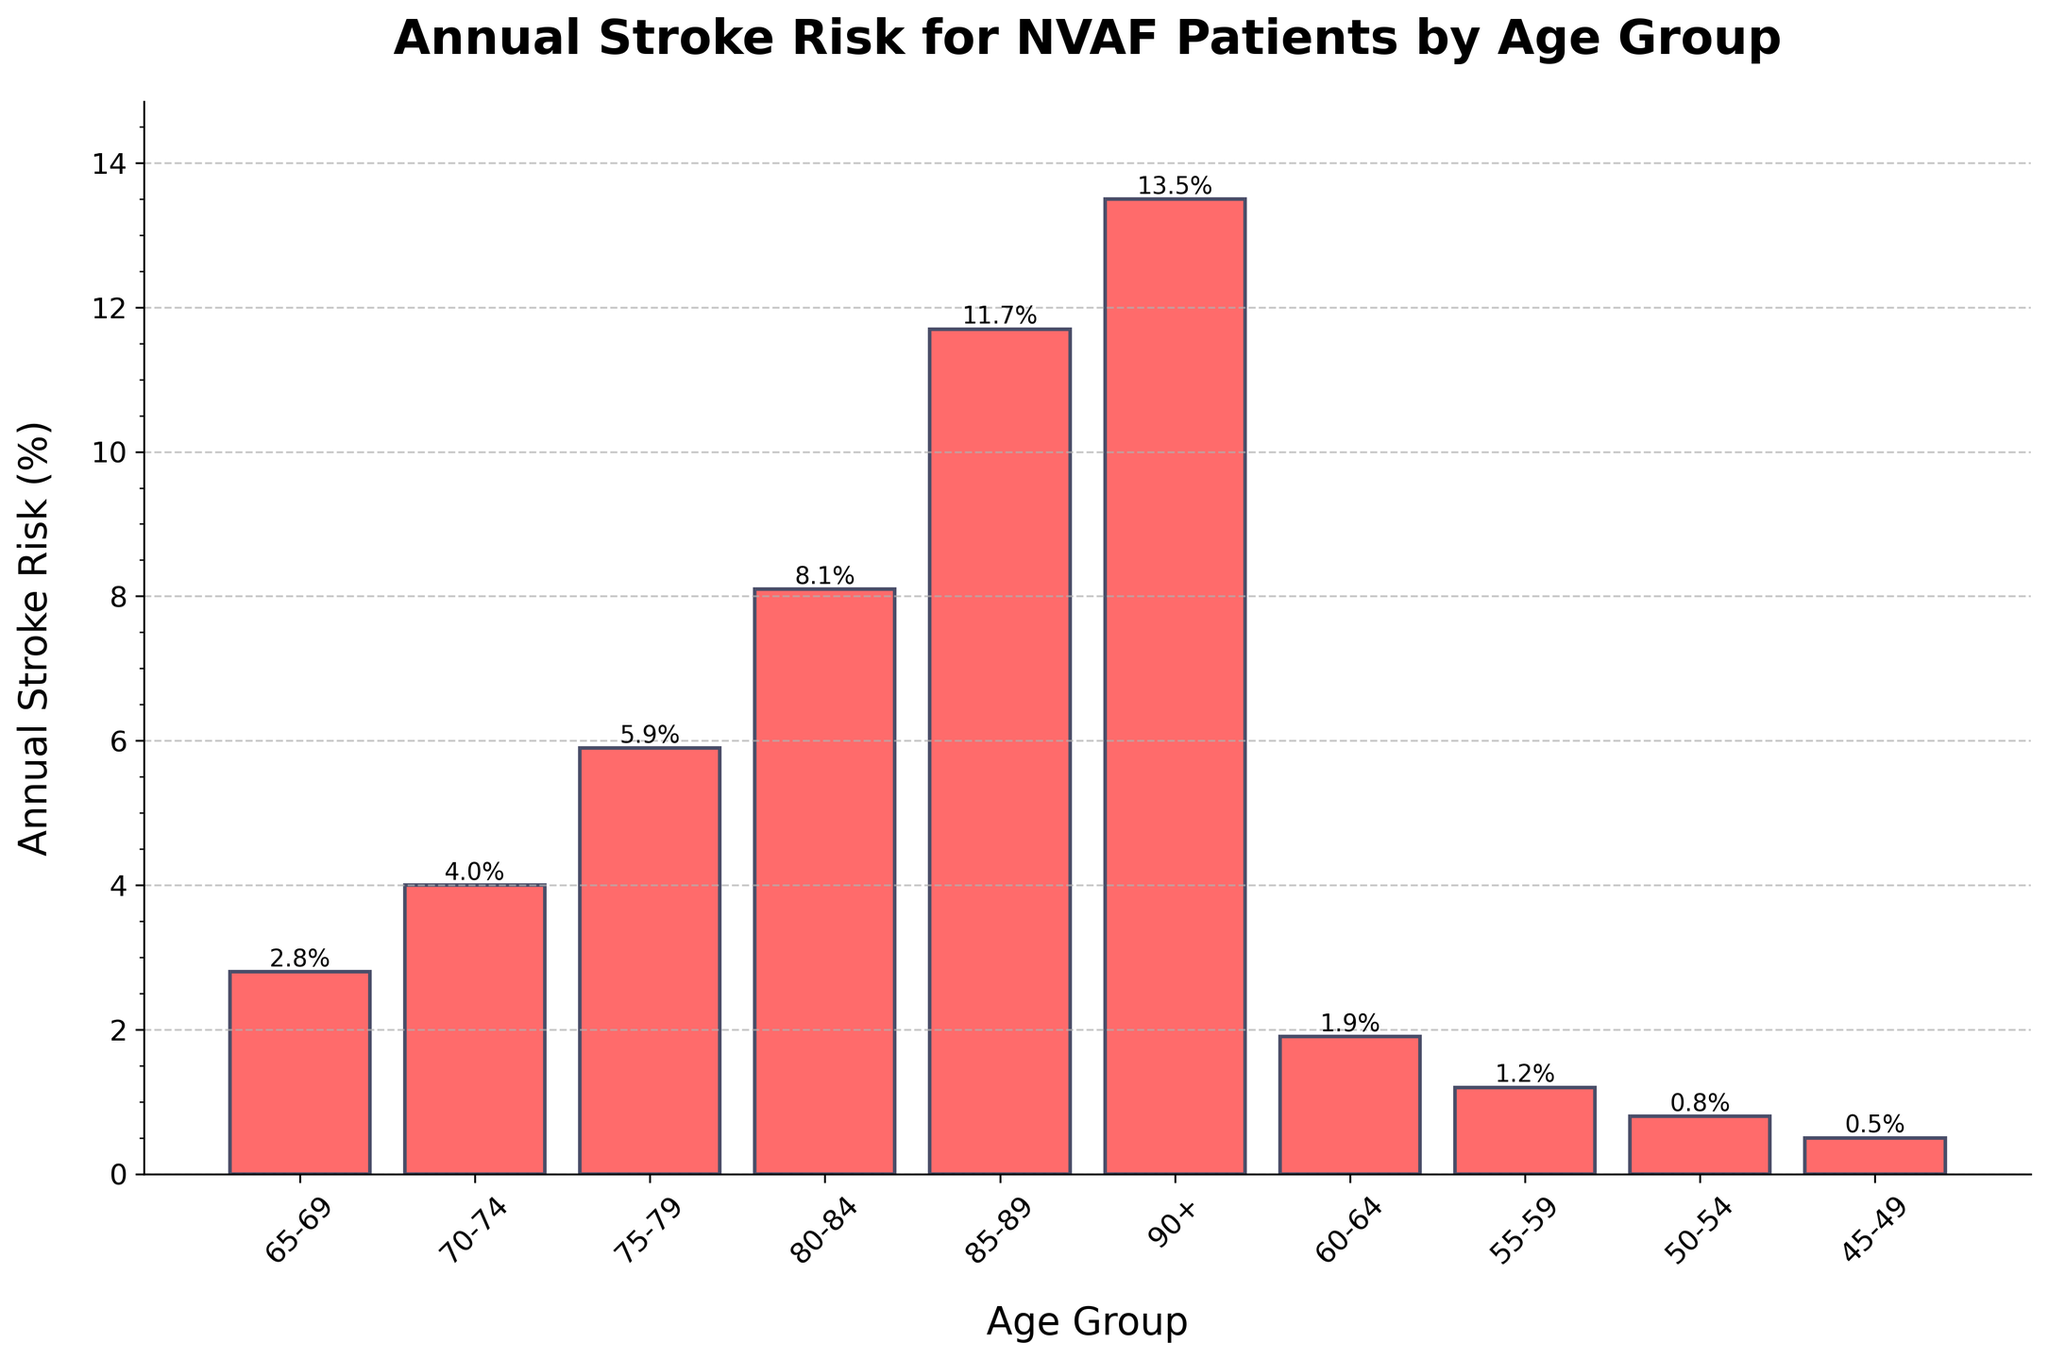What's the stroke risk for NVAF patients aged 70-74? The bar labeled "70-74" in the chart shows an annual stroke risk of 4.0%.
Answer: 4.0% Which age group has the highest annual stroke risk? By reviewing the heights of all bars, the tallest bar represents the "90+" age group with a stroke risk of 13.5%.
Answer: 90+ How much greater is the stroke risk for NVAF patients aged 85-89 compared to those aged 75-79? The bar for "85-89" shows an 11.7% risk, and the bar for "75-79" shows a 5.9% risk. The difference is 11.7% - 5.9% = 5.8%.
Answer: 5.8% What's the average annual stroke risk for NVAF patients aged 60-69? The bars for the age groups "60-64" and "65-69" show risks of 1.9% and 2.8%, respectively. The average is (1.9 + 2.8) / 2 = 2.35%.
Answer: 2.35% Is the stroke risk for patients aged 80-84 more than twice that of patients aged 70-74? The bar for "80-84" shows an 8.1% risk, and the bar for "70-74" shows a 4.0% risk. Twice the 4.0% risk is 8.0%. Since 8.1% is greater than 8.0%, the stroke risk for "80-84" is more than twice that of "70-74".
Answer: Yes Does any age group have a stroke risk below 1%? The bars for the age groups "45-49", "50-54", and "55-59" show stroke risks of 0.5%, 0.8%, and 1.2%, respectively. Only "45-49" and "50-54" have risks below 1%.
Answer: Yes By how much does the stroke risk increase from the age group "50-54" to "65-69"? The bar for "50-54" shows a 0.8% risk, and the bar for "65-69" shows a 2.8% risk. The increase is 2.8% - 0.8% = 2.0%.
Answer: 2.0% What is the median annual stroke risk for all age groups? To find the median, the stroke risks are ordered: 0.5%, 0.8%, 1.2%, 1.9%, 2.8%, 4.0%, 5.9%, 8.1%, 11.7%, 13.5%. The middle value for 10 data points is the average of the 5th and 6th values, (2.8 + 4.0) / 2 = 3.4%.
Answer: 3.4% Which age group has a stroke risk closest to 5%? Reviewing the bar heights, the "75-79" age group has a stroke risk of 5.9%, which is the closest to 5%.
Answer: 75-79 